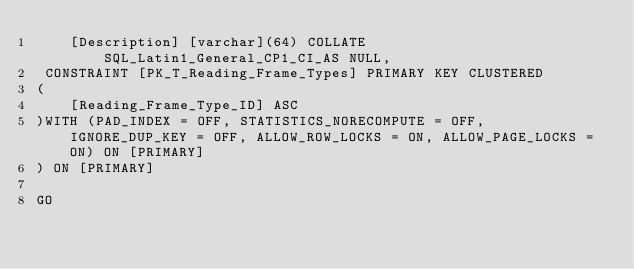Convert code to text. <code><loc_0><loc_0><loc_500><loc_500><_SQL_>	[Description] [varchar](64) COLLATE SQL_Latin1_General_CP1_CI_AS NULL,
 CONSTRAINT [PK_T_Reading_Frame_Types] PRIMARY KEY CLUSTERED 
(
	[Reading_Frame_Type_ID] ASC
)WITH (PAD_INDEX = OFF, STATISTICS_NORECOMPUTE = OFF, IGNORE_DUP_KEY = OFF, ALLOW_ROW_LOCKS = ON, ALLOW_PAGE_LOCKS = ON) ON [PRIMARY]
) ON [PRIMARY]

GO
</code> 